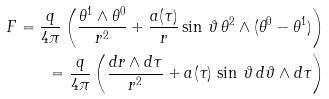<formula> <loc_0><loc_0><loc_500><loc_500>F = \frac { q } { 4 \pi } \left ( \frac { \theta ^ { 1 } \wedge \theta ^ { 0 } } { r ^ { 2 } } + \frac { a ( \tau ) } { r } \sin \, \vartheta \, \theta ^ { 2 } \wedge ( \theta ^ { 0 } - \theta ^ { 1 } ) \right ) \\ = \frac { q } { 4 \pi } \left ( \frac { d r \wedge d \tau } { r ^ { 2 } } + a ( \tau ) \, \sin \, \vartheta \, d \vartheta \wedge d \tau \right )</formula> 